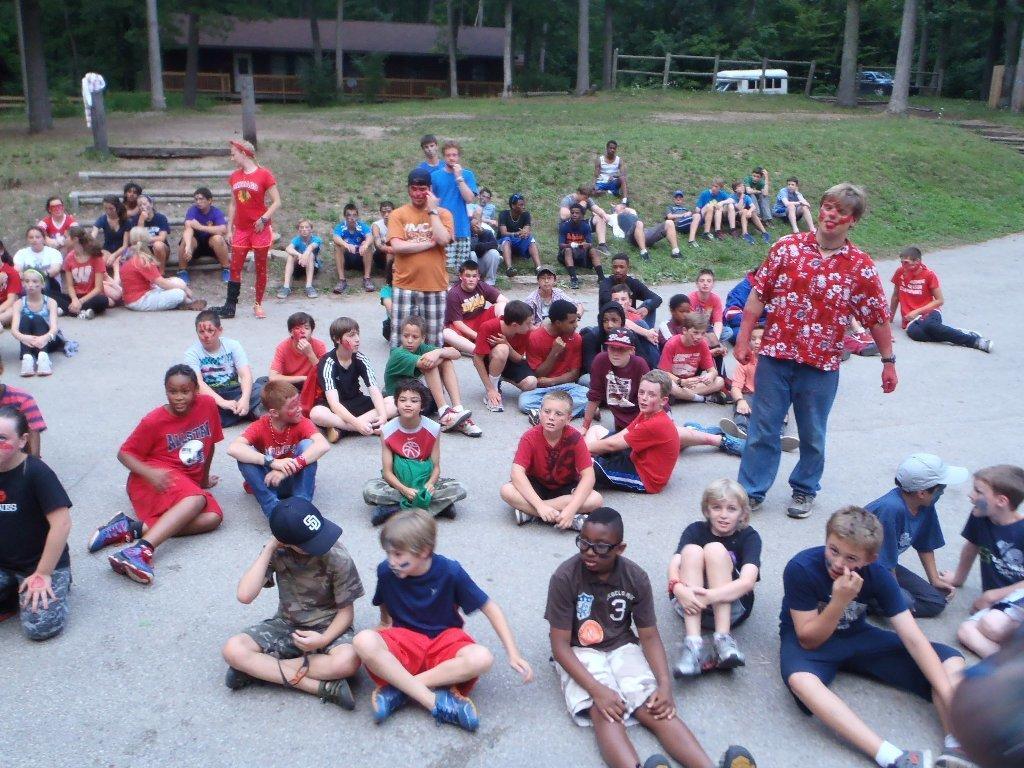In one or two sentences, can you explain what this image depicts? As we can see in the image there are group of people, stairs, trees and buildings. There is grass and two vehicles. 